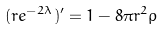Convert formula to latex. <formula><loc_0><loc_0><loc_500><loc_500>( r e ^ { - 2 \lambda } ) ^ { \prime } = 1 - 8 \pi r ^ { 2 } \rho</formula> 